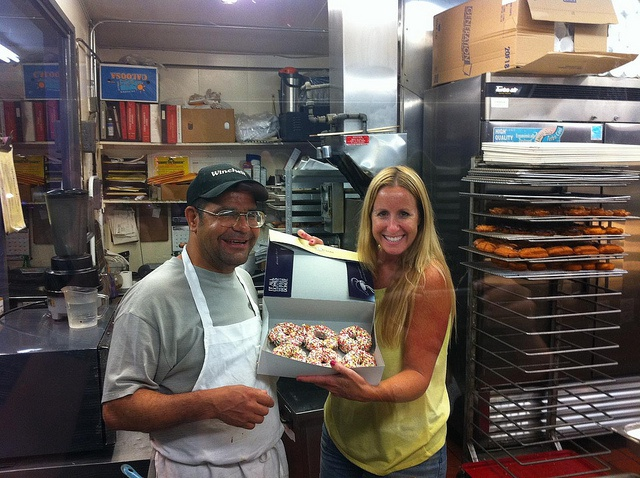Describe the objects in this image and their specific colors. I can see people in gray, darkgray, black, and maroon tones, people in gray, olive, black, maroon, and brown tones, refrigerator in gray, black, lightgray, and darkgray tones, book in gray, maroon, brown, and black tones, and donut in gray, ivory, tan, and brown tones in this image. 